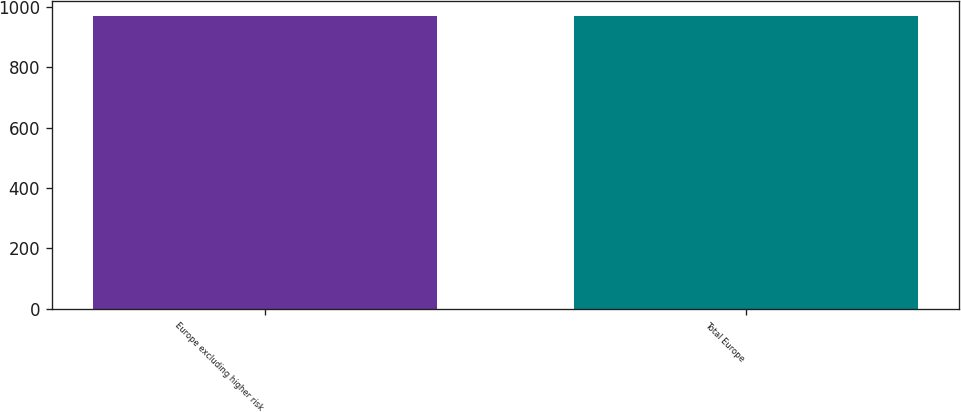Convert chart. <chart><loc_0><loc_0><loc_500><loc_500><bar_chart><fcel>Europe excluding higher risk<fcel>Total Europe<nl><fcel>970<fcel>970.1<nl></chart> 